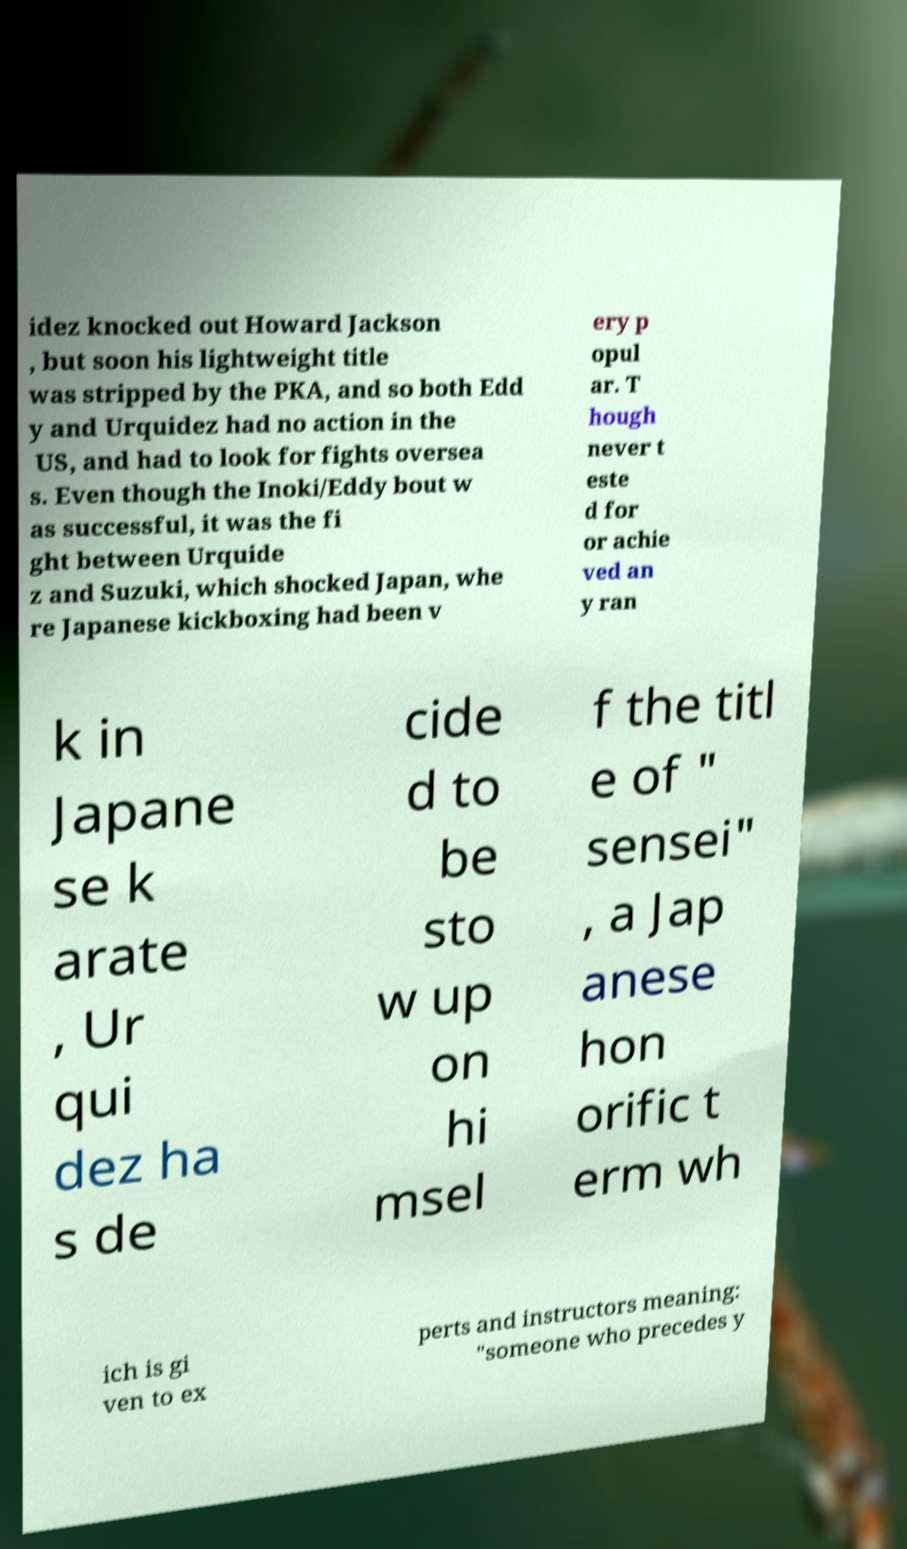Can you read and provide the text displayed in the image?This photo seems to have some interesting text. Can you extract and type it out for me? idez knocked out Howard Jackson , but soon his lightweight title was stripped by the PKA, and so both Edd y and Urquidez had no action in the US, and had to look for fights oversea s. Even though the Inoki/Eddy bout w as successful, it was the fi ght between Urquide z and Suzuki, which shocked Japan, whe re Japanese kickboxing had been v ery p opul ar. T hough never t este d for or achie ved an y ran k in Japane se k arate , Ur qui dez ha s de cide d to be sto w up on hi msel f the titl e of " sensei" , a Jap anese hon orific t erm wh ich is gi ven to ex perts and instructors meaning: "someone who precedes y 